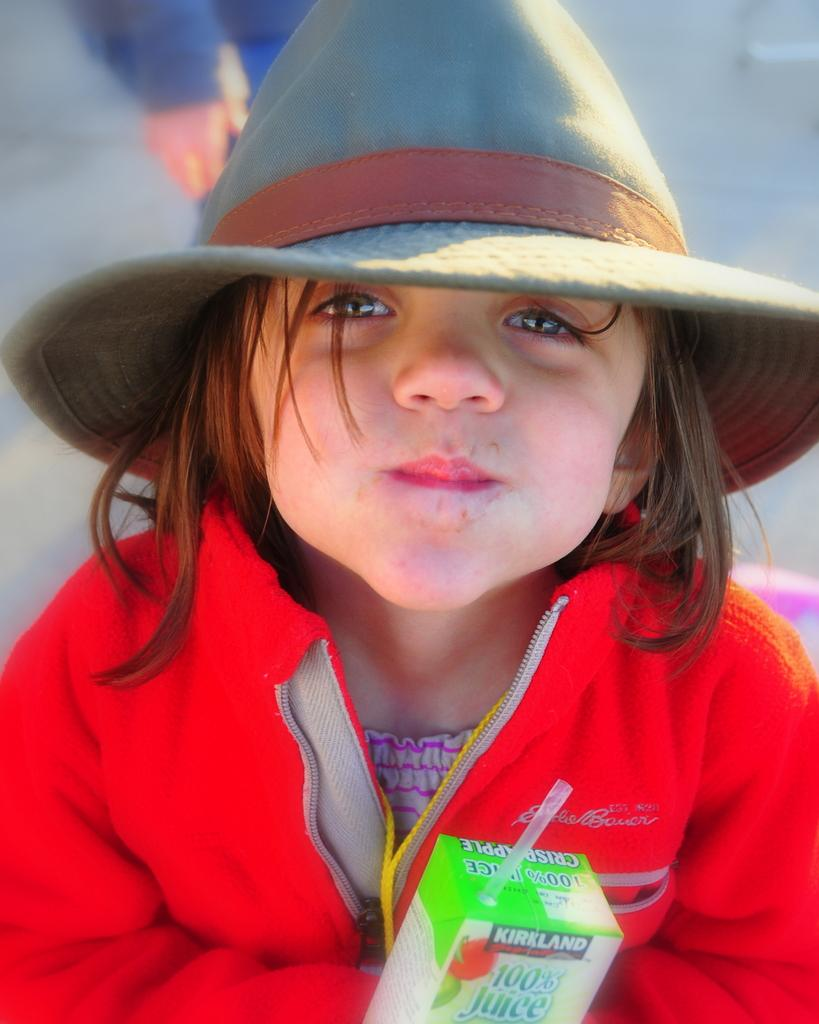Who is the main subject in the image? There is a girl in the image. What is the girl wearing? The girl is wearing a red dress and a hat. Can you describe the person behind the girl? There is a person behind the girl, but their appearance is not specified in the facts. What object is present in the image that is related to packaging? There is a paper box in the image. What is on the paper box? There is a straw on the paper box. What year is depicted in the image? The facts provided do not mention any specific year, so it cannot be determined from the image. What type of drink is being served in the straw? There is no drink present in the image, only a straw on the paper box. 